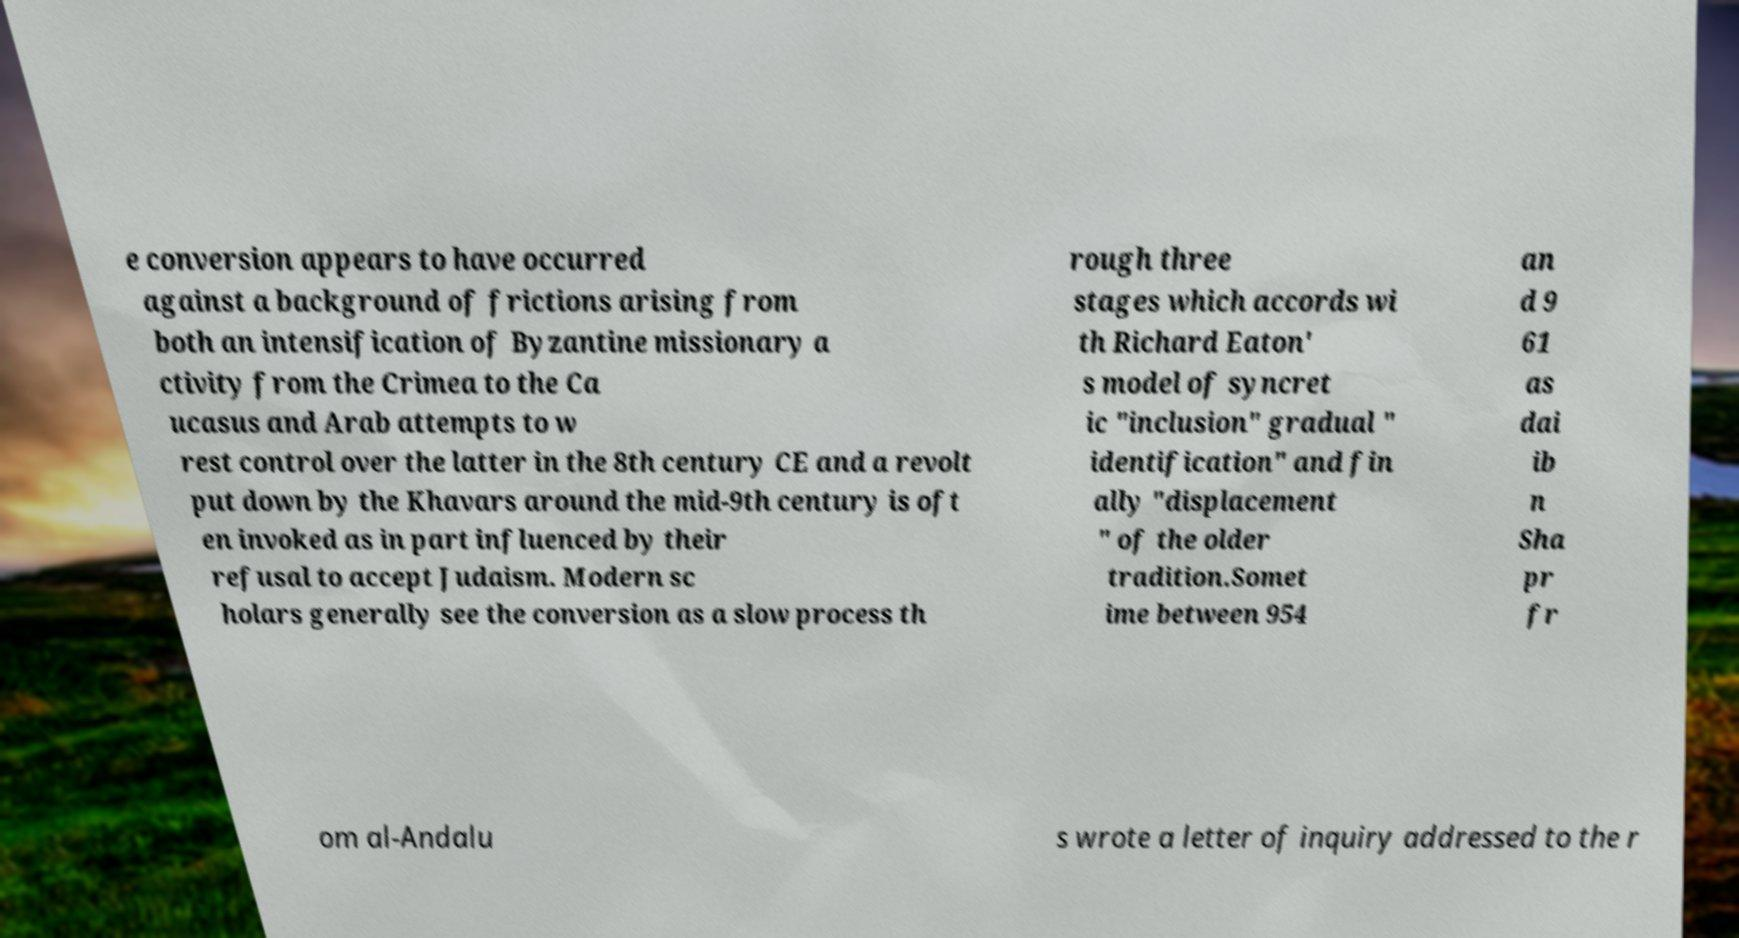Can you accurately transcribe the text from the provided image for me? e conversion appears to have occurred against a background of frictions arising from both an intensification of Byzantine missionary a ctivity from the Crimea to the Ca ucasus and Arab attempts to w rest control over the latter in the 8th century CE and a revolt put down by the Khavars around the mid-9th century is oft en invoked as in part influenced by their refusal to accept Judaism. Modern sc holars generally see the conversion as a slow process th rough three stages which accords wi th Richard Eaton' s model of syncret ic "inclusion" gradual " identification" and fin ally "displacement " of the older tradition.Somet ime between 954 an d 9 61 as dai ib n Sha pr fr om al-Andalu s wrote a letter of inquiry addressed to the r 